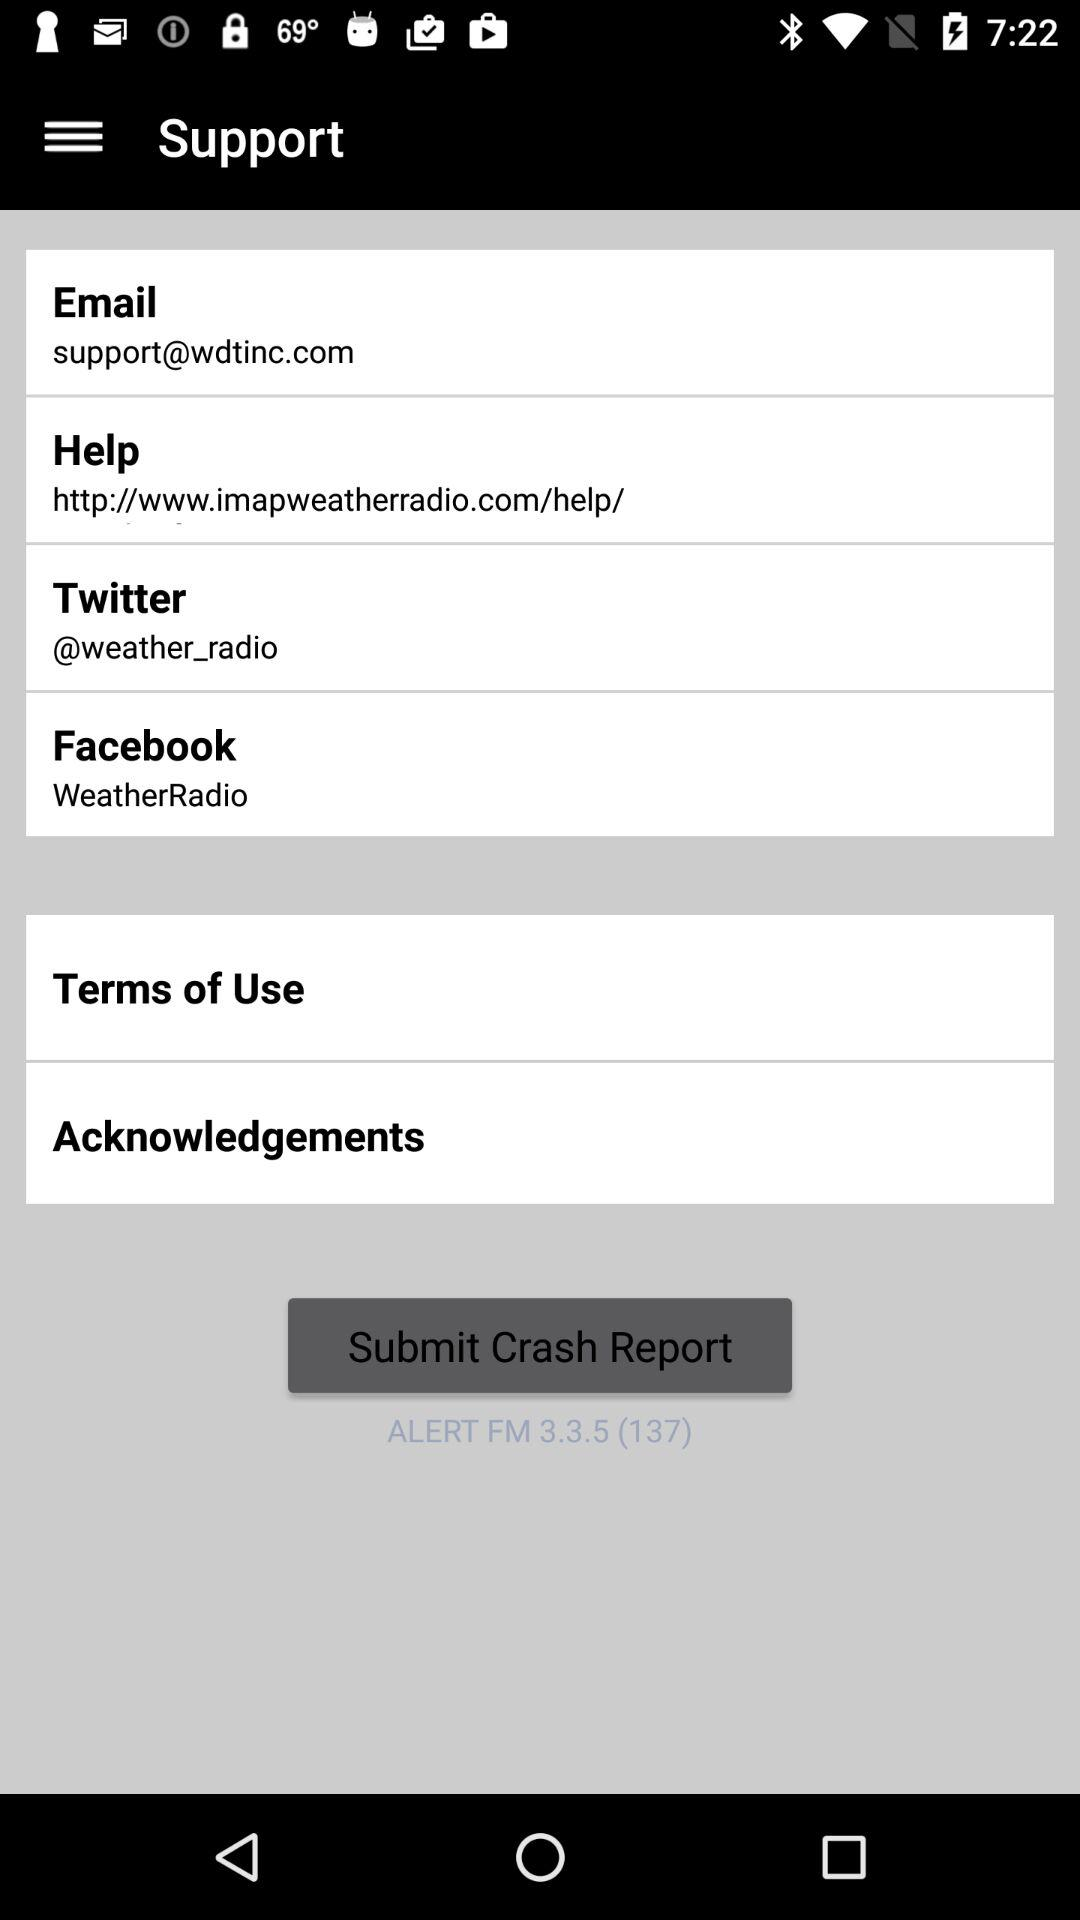What is the version number? The version number is 3.3.5 (137). 